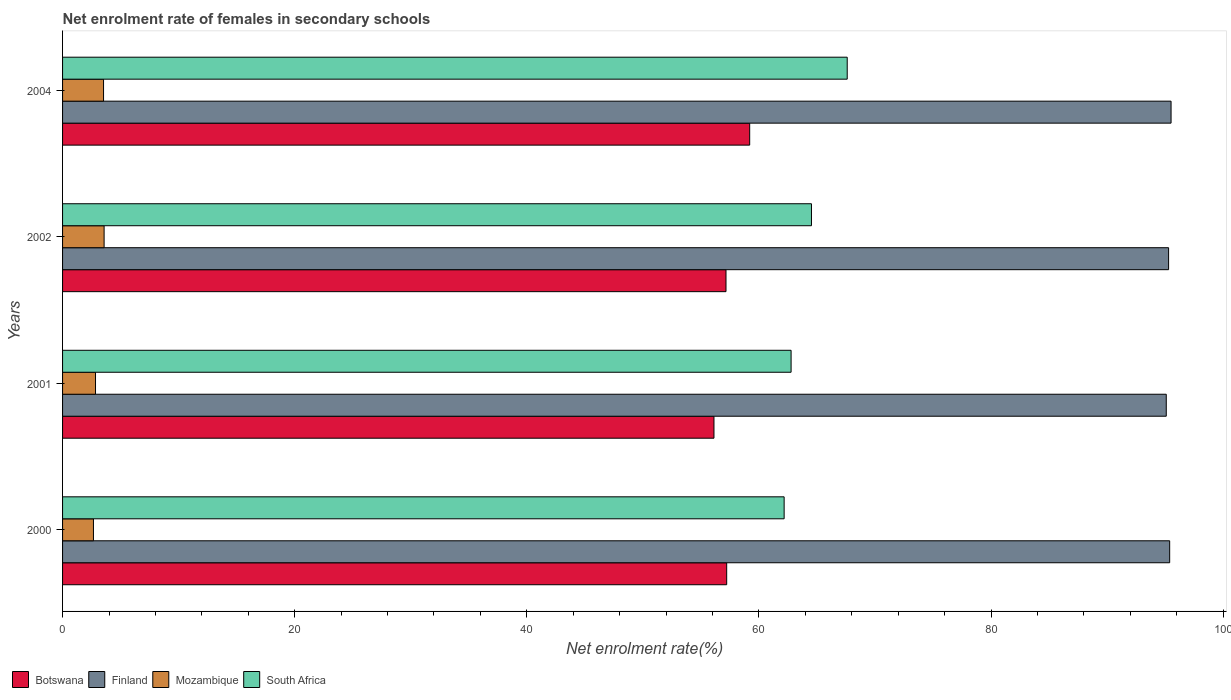How many different coloured bars are there?
Ensure brevity in your answer.  4. How many groups of bars are there?
Your answer should be compact. 4. How many bars are there on the 2nd tick from the top?
Your answer should be compact. 4. How many bars are there on the 2nd tick from the bottom?
Provide a succinct answer. 4. What is the label of the 2nd group of bars from the top?
Your answer should be compact. 2002. What is the net enrolment rate of females in secondary schools in Botswana in 2001?
Provide a succinct answer. 56.12. Across all years, what is the maximum net enrolment rate of females in secondary schools in Finland?
Offer a very short reply. 95.51. Across all years, what is the minimum net enrolment rate of females in secondary schools in South Africa?
Provide a succinct answer. 62.17. What is the total net enrolment rate of females in secondary schools in South Africa in the graph?
Offer a terse response. 257.07. What is the difference between the net enrolment rate of females in secondary schools in Botswana in 2000 and that in 2004?
Provide a succinct answer. -1.98. What is the difference between the net enrolment rate of females in secondary schools in Finland in 2004 and the net enrolment rate of females in secondary schools in South Africa in 2000?
Make the answer very short. 33.34. What is the average net enrolment rate of females in secondary schools in Finland per year?
Provide a short and direct response. 95.32. In the year 2002, what is the difference between the net enrolment rate of females in secondary schools in South Africa and net enrolment rate of females in secondary schools in Mozambique?
Offer a terse response. 60.94. What is the ratio of the net enrolment rate of females in secondary schools in Botswana in 2000 to that in 2002?
Provide a short and direct response. 1. Is the net enrolment rate of females in secondary schools in Botswana in 2000 less than that in 2001?
Offer a terse response. No. Is the difference between the net enrolment rate of females in secondary schools in South Africa in 2001 and 2002 greater than the difference between the net enrolment rate of females in secondary schools in Mozambique in 2001 and 2002?
Your answer should be compact. No. What is the difference between the highest and the second highest net enrolment rate of females in secondary schools in Mozambique?
Your response must be concise. 0.05. What is the difference between the highest and the lowest net enrolment rate of females in secondary schools in Mozambique?
Offer a terse response. 0.92. Is the sum of the net enrolment rate of females in secondary schools in Botswana in 2000 and 2004 greater than the maximum net enrolment rate of females in secondary schools in Mozambique across all years?
Make the answer very short. Yes. What does the 1st bar from the top in 2001 represents?
Provide a succinct answer. South Africa. What does the 4th bar from the bottom in 2000 represents?
Offer a very short reply. South Africa. Is it the case that in every year, the sum of the net enrolment rate of females in secondary schools in South Africa and net enrolment rate of females in secondary schools in Mozambique is greater than the net enrolment rate of females in secondary schools in Finland?
Provide a short and direct response. No. How many bars are there?
Provide a succinct answer. 16. How many years are there in the graph?
Your answer should be compact. 4. Does the graph contain grids?
Ensure brevity in your answer.  No. Where does the legend appear in the graph?
Offer a terse response. Bottom left. What is the title of the graph?
Give a very brief answer. Net enrolment rate of females in secondary schools. What is the label or title of the X-axis?
Provide a short and direct response. Net enrolment rate(%). What is the Net enrolment rate(%) in Botswana in 2000?
Offer a terse response. 57.22. What is the Net enrolment rate(%) in Finland in 2000?
Keep it short and to the point. 95.39. What is the Net enrolment rate(%) of Mozambique in 2000?
Make the answer very short. 2.66. What is the Net enrolment rate(%) of South Africa in 2000?
Keep it short and to the point. 62.17. What is the Net enrolment rate(%) of Botswana in 2001?
Make the answer very short. 56.12. What is the Net enrolment rate(%) of Finland in 2001?
Provide a short and direct response. 95.09. What is the Net enrolment rate(%) of Mozambique in 2001?
Offer a very short reply. 2.84. What is the Net enrolment rate(%) in South Africa in 2001?
Provide a succinct answer. 62.77. What is the Net enrolment rate(%) in Botswana in 2002?
Offer a terse response. 57.16. What is the Net enrolment rate(%) of Finland in 2002?
Provide a succinct answer. 95.29. What is the Net enrolment rate(%) of Mozambique in 2002?
Your answer should be very brief. 3.58. What is the Net enrolment rate(%) of South Africa in 2002?
Provide a short and direct response. 64.52. What is the Net enrolment rate(%) of Botswana in 2004?
Provide a succinct answer. 59.2. What is the Net enrolment rate(%) of Finland in 2004?
Make the answer very short. 95.51. What is the Net enrolment rate(%) in Mozambique in 2004?
Give a very brief answer. 3.53. What is the Net enrolment rate(%) of South Africa in 2004?
Your answer should be compact. 67.6. Across all years, what is the maximum Net enrolment rate(%) of Botswana?
Keep it short and to the point. 59.2. Across all years, what is the maximum Net enrolment rate(%) of Finland?
Your answer should be compact. 95.51. Across all years, what is the maximum Net enrolment rate(%) of Mozambique?
Make the answer very short. 3.58. Across all years, what is the maximum Net enrolment rate(%) in South Africa?
Offer a very short reply. 67.6. Across all years, what is the minimum Net enrolment rate(%) of Botswana?
Provide a short and direct response. 56.12. Across all years, what is the minimum Net enrolment rate(%) in Finland?
Your answer should be compact. 95.09. Across all years, what is the minimum Net enrolment rate(%) of Mozambique?
Your answer should be compact. 2.66. Across all years, what is the minimum Net enrolment rate(%) of South Africa?
Your answer should be compact. 62.17. What is the total Net enrolment rate(%) of Botswana in the graph?
Your answer should be very brief. 229.71. What is the total Net enrolment rate(%) in Finland in the graph?
Your response must be concise. 381.28. What is the total Net enrolment rate(%) of Mozambique in the graph?
Offer a terse response. 12.61. What is the total Net enrolment rate(%) of South Africa in the graph?
Give a very brief answer. 257.07. What is the difference between the Net enrolment rate(%) in Botswana in 2000 and that in 2001?
Your response must be concise. 1.1. What is the difference between the Net enrolment rate(%) of Finland in 2000 and that in 2001?
Your answer should be very brief. 0.29. What is the difference between the Net enrolment rate(%) in Mozambique in 2000 and that in 2001?
Your answer should be compact. -0.18. What is the difference between the Net enrolment rate(%) of South Africa in 2000 and that in 2001?
Offer a very short reply. -0.6. What is the difference between the Net enrolment rate(%) in Botswana in 2000 and that in 2002?
Ensure brevity in your answer.  0.06. What is the difference between the Net enrolment rate(%) in Finland in 2000 and that in 2002?
Provide a succinct answer. 0.09. What is the difference between the Net enrolment rate(%) of Mozambique in 2000 and that in 2002?
Your answer should be compact. -0.92. What is the difference between the Net enrolment rate(%) of South Africa in 2000 and that in 2002?
Your response must be concise. -2.36. What is the difference between the Net enrolment rate(%) of Botswana in 2000 and that in 2004?
Your answer should be very brief. -1.98. What is the difference between the Net enrolment rate(%) of Finland in 2000 and that in 2004?
Keep it short and to the point. -0.12. What is the difference between the Net enrolment rate(%) of Mozambique in 2000 and that in 2004?
Make the answer very short. -0.87. What is the difference between the Net enrolment rate(%) of South Africa in 2000 and that in 2004?
Offer a very short reply. -5.44. What is the difference between the Net enrolment rate(%) of Botswana in 2001 and that in 2002?
Offer a terse response. -1.04. What is the difference between the Net enrolment rate(%) of Finland in 2001 and that in 2002?
Your response must be concise. -0.2. What is the difference between the Net enrolment rate(%) in Mozambique in 2001 and that in 2002?
Offer a terse response. -0.74. What is the difference between the Net enrolment rate(%) of South Africa in 2001 and that in 2002?
Your answer should be very brief. -1.76. What is the difference between the Net enrolment rate(%) of Botswana in 2001 and that in 2004?
Make the answer very short. -3.08. What is the difference between the Net enrolment rate(%) in Finland in 2001 and that in 2004?
Your answer should be compact. -0.41. What is the difference between the Net enrolment rate(%) of Mozambique in 2001 and that in 2004?
Offer a terse response. -0.69. What is the difference between the Net enrolment rate(%) of South Africa in 2001 and that in 2004?
Your answer should be very brief. -4.84. What is the difference between the Net enrolment rate(%) in Botswana in 2002 and that in 2004?
Your answer should be very brief. -2.04. What is the difference between the Net enrolment rate(%) in Finland in 2002 and that in 2004?
Give a very brief answer. -0.21. What is the difference between the Net enrolment rate(%) in Mozambique in 2002 and that in 2004?
Provide a succinct answer. 0.05. What is the difference between the Net enrolment rate(%) of South Africa in 2002 and that in 2004?
Your answer should be compact. -3.08. What is the difference between the Net enrolment rate(%) in Botswana in 2000 and the Net enrolment rate(%) in Finland in 2001?
Make the answer very short. -37.87. What is the difference between the Net enrolment rate(%) in Botswana in 2000 and the Net enrolment rate(%) in Mozambique in 2001?
Make the answer very short. 54.38. What is the difference between the Net enrolment rate(%) in Botswana in 2000 and the Net enrolment rate(%) in South Africa in 2001?
Your answer should be very brief. -5.55. What is the difference between the Net enrolment rate(%) in Finland in 2000 and the Net enrolment rate(%) in Mozambique in 2001?
Your answer should be very brief. 92.55. What is the difference between the Net enrolment rate(%) of Finland in 2000 and the Net enrolment rate(%) of South Africa in 2001?
Offer a terse response. 32.62. What is the difference between the Net enrolment rate(%) in Mozambique in 2000 and the Net enrolment rate(%) in South Africa in 2001?
Your answer should be compact. -60.11. What is the difference between the Net enrolment rate(%) of Botswana in 2000 and the Net enrolment rate(%) of Finland in 2002?
Keep it short and to the point. -38.07. What is the difference between the Net enrolment rate(%) of Botswana in 2000 and the Net enrolment rate(%) of Mozambique in 2002?
Provide a succinct answer. 53.64. What is the difference between the Net enrolment rate(%) in Botswana in 2000 and the Net enrolment rate(%) in South Africa in 2002?
Give a very brief answer. -7.3. What is the difference between the Net enrolment rate(%) in Finland in 2000 and the Net enrolment rate(%) in Mozambique in 2002?
Give a very brief answer. 91.81. What is the difference between the Net enrolment rate(%) of Finland in 2000 and the Net enrolment rate(%) of South Africa in 2002?
Offer a terse response. 30.86. What is the difference between the Net enrolment rate(%) in Mozambique in 2000 and the Net enrolment rate(%) in South Africa in 2002?
Ensure brevity in your answer.  -61.86. What is the difference between the Net enrolment rate(%) of Botswana in 2000 and the Net enrolment rate(%) of Finland in 2004?
Your response must be concise. -38.29. What is the difference between the Net enrolment rate(%) in Botswana in 2000 and the Net enrolment rate(%) in Mozambique in 2004?
Ensure brevity in your answer.  53.69. What is the difference between the Net enrolment rate(%) of Botswana in 2000 and the Net enrolment rate(%) of South Africa in 2004?
Offer a very short reply. -10.38. What is the difference between the Net enrolment rate(%) in Finland in 2000 and the Net enrolment rate(%) in Mozambique in 2004?
Give a very brief answer. 91.86. What is the difference between the Net enrolment rate(%) of Finland in 2000 and the Net enrolment rate(%) of South Africa in 2004?
Your response must be concise. 27.78. What is the difference between the Net enrolment rate(%) in Mozambique in 2000 and the Net enrolment rate(%) in South Africa in 2004?
Your answer should be compact. -64.94. What is the difference between the Net enrolment rate(%) in Botswana in 2001 and the Net enrolment rate(%) in Finland in 2002?
Offer a very short reply. -39.17. What is the difference between the Net enrolment rate(%) in Botswana in 2001 and the Net enrolment rate(%) in Mozambique in 2002?
Your answer should be very brief. 52.54. What is the difference between the Net enrolment rate(%) in Botswana in 2001 and the Net enrolment rate(%) in South Africa in 2002?
Make the answer very short. -8.4. What is the difference between the Net enrolment rate(%) in Finland in 2001 and the Net enrolment rate(%) in Mozambique in 2002?
Give a very brief answer. 91.51. What is the difference between the Net enrolment rate(%) of Finland in 2001 and the Net enrolment rate(%) of South Africa in 2002?
Your response must be concise. 30.57. What is the difference between the Net enrolment rate(%) in Mozambique in 2001 and the Net enrolment rate(%) in South Africa in 2002?
Offer a very short reply. -61.68. What is the difference between the Net enrolment rate(%) of Botswana in 2001 and the Net enrolment rate(%) of Finland in 2004?
Your answer should be very brief. -39.38. What is the difference between the Net enrolment rate(%) of Botswana in 2001 and the Net enrolment rate(%) of Mozambique in 2004?
Offer a very short reply. 52.59. What is the difference between the Net enrolment rate(%) of Botswana in 2001 and the Net enrolment rate(%) of South Africa in 2004?
Provide a short and direct response. -11.48. What is the difference between the Net enrolment rate(%) of Finland in 2001 and the Net enrolment rate(%) of Mozambique in 2004?
Provide a succinct answer. 91.56. What is the difference between the Net enrolment rate(%) of Finland in 2001 and the Net enrolment rate(%) of South Africa in 2004?
Your response must be concise. 27.49. What is the difference between the Net enrolment rate(%) of Mozambique in 2001 and the Net enrolment rate(%) of South Africa in 2004?
Make the answer very short. -64.76. What is the difference between the Net enrolment rate(%) of Botswana in 2002 and the Net enrolment rate(%) of Finland in 2004?
Give a very brief answer. -38.35. What is the difference between the Net enrolment rate(%) in Botswana in 2002 and the Net enrolment rate(%) in Mozambique in 2004?
Your answer should be compact. 53.63. What is the difference between the Net enrolment rate(%) in Botswana in 2002 and the Net enrolment rate(%) in South Africa in 2004?
Your answer should be very brief. -10.44. What is the difference between the Net enrolment rate(%) in Finland in 2002 and the Net enrolment rate(%) in Mozambique in 2004?
Offer a terse response. 91.76. What is the difference between the Net enrolment rate(%) of Finland in 2002 and the Net enrolment rate(%) of South Africa in 2004?
Your answer should be compact. 27.69. What is the difference between the Net enrolment rate(%) in Mozambique in 2002 and the Net enrolment rate(%) in South Africa in 2004?
Your answer should be very brief. -64.02. What is the average Net enrolment rate(%) in Botswana per year?
Offer a very short reply. 57.43. What is the average Net enrolment rate(%) in Finland per year?
Your answer should be very brief. 95.32. What is the average Net enrolment rate(%) of Mozambique per year?
Offer a very short reply. 3.15. What is the average Net enrolment rate(%) in South Africa per year?
Offer a very short reply. 64.27. In the year 2000, what is the difference between the Net enrolment rate(%) of Botswana and Net enrolment rate(%) of Finland?
Your answer should be compact. -38.17. In the year 2000, what is the difference between the Net enrolment rate(%) in Botswana and Net enrolment rate(%) in Mozambique?
Offer a very short reply. 54.56. In the year 2000, what is the difference between the Net enrolment rate(%) in Botswana and Net enrolment rate(%) in South Africa?
Provide a succinct answer. -4.95. In the year 2000, what is the difference between the Net enrolment rate(%) of Finland and Net enrolment rate(%) of Mozambique?
Your response must be concise. 92.72. In the year 2000, what is the difference between the Net enrolment rate(%) in Finland and Net enrolment rate(%) in South Africa?
Your answer should be very brief. 33.22. In the year 2000, what is the difference between the Net enrolment rate(%) of Mozambique and Net enrolment rate(%) of South Africa?
Your answer should be very brief. -59.51. In the year 2001, what is the difference between the Net enrolment rate(%) of Botswana and Net enrolment rate(%) of Finland?
Make the answer very short. -38.97. In the year 2001, what is the difference between the Net enrolment rate(%) of Botswana and Net enrolment rate(%) of Mozambique?
Give a very brief answer. 53.28. In the year 2001, what is the difference between the Net enrolment rate(%) of Botswana and Net enrolment rate(%) of South Africa?
Provide a short and direct response. -6.64. In the year 2001, what is the difference between the Net enrolment rate(%) of Finland and Net enrolment rate(%) of Mozambique?
Offer a terse response. 92.25. In the year 2001, what is the difference between the Net enrolment rate(%) in Finland and Net enrolment rate(%) in South Africa?
Offer a very short reply. 32.32. In the year 2001, what is the difference between the Net enrolment rate(%) in Mozambique and Net enrolment rate(%) in South Africa?
Ensure brevity in your answer.  -59.93. In the year 2002, what is the difference between the Net enrolment rate(%) in Botswana and Net enrolment rate(%) in Finland?
Your answer should be compact. -38.13. In the year 2002, what is the difference between the Net enrolment rate(%) of Botswana and Net enrolment rate(%) of Mozambique?
Your answer should be compact. 53.58. In the year 2002, what is the difference between the Net enrolment rate(%) of Botswana and Net enrolment rate(%) of South Africa?
Offer a very short reply. -7.36. In the year 2002, what is the difference between the Net enrolment rate(%) in Finland and Net enrolment rate(%) in Mozambique?
Your response must be concise. 91.71. In the year 2002, what is the difference between the Net enrolment rate(%) of Finland and Net enrolment rate(%) of South Africa?
Your response must be concise. 30.77. In the year 2002, what is the difference between the Net enrolment rate(%) in Mozambique and Net enrolment rate(%) in South Africa?
Provide a succinct answer. -60.94. In the year 2004, what is the difference between the Net enrolment rate(%) of Botswana and Net enrolment rate(%) of Finland?
Keep it short and to the point. -36.31. In the year 2004, what is the difference between the Net enrolment rate(%) in Botswana and Net enrolment rate(%) in Mozambique?
Ensure brevity in your answer.  55.67. In the year 2004, what is the difference between the Net enrolment rate(%) of Botswana and Net enrolment rate(%) of South Africa?
Make the answer very short. -8.4. In the year 2004, what is the difference between the Net enrolment rate(%) in Finland and Net enrolment rate(%) in Mozambique?
Your answer should be compact. 91.98. In the year 2004, what is the difference between the Net enrolment rate(%) in Finland and Net enrolment rate(%) in South Africa?
Your answer should be compact. 27.9. In the year 2004, what is the difference between the Net enrolment rate(%) in Mozambique and Net enrolment rate(%) in South Africa?
Offer a very short reply. -64.07. What is the ratio of the Net enrolment rate(%) in Botswana in 2000 to that in 2001?
Keep it short and to the point. 1.02. What is the ratio of the Net enrolment rate(%) of Finland in 2000 to that in 2001?
Keep it short and to the point. 1. What is the ratio of the Net enrolment rate(%) of Mozambique in 2000 to that in 2001?
Keep it short and to the point. 0.94. What is the ratio of the Net enrolment rate(%) in Finland in 2000 to that in 2002?
Your answer should be very brief. 1. What is the ratio of the Net enrolment rate(%) in Mozambique in 2000 to that in 2002?
Your answer should be compact. 0.74. What is the ratio of the Net enrolment rate(%) of South Africa in 2000 to that in 2002?
Your answer should be compact. 0.96. What is the ratio of the Net enrolment rate(%) of Botswana in 2000 to that in 2004?
Your answer should be very brief. 0.97. What is the ratio of the Net enrolment rate(%) of Finland in 2000 to that in 2004?
Make the answer very short. 1. What is the ratio of the Net enrolment rate(%) of Mozambique in 2000 to that in 2004?
Ensure brevity in your answer.  0.75. What is the ratio of the Net enrolment rate(%) in South Africa in 2000 to that in 2004?
Ensure brevity in your answer.  0.92. What is the ratio of the Net enrolment rate(%) of Botswana in 2001 to that in 2002?
Provide a succinct answer. 0.98. What is the ratio of the Net enrolment rate(%) in Finland in 2001 to that in 2002?
Ensure brevity in your answer.  1. What is the ratio of the Net enrolment rate(%) in Mozambique in 2001 to that in 2002?
Provide a succinct answer. 0.79. What is the ratio of the Net enrolment rate(%) in South Africa in 2001 to that in 2002?
Offer a terse response. 0.97. What is the ratio of the Net enrolment rate(%) of Botswana in 2001 to that in 2004?
Give a very brief answer. 0.95. What is the ratio of the Net enrolment rate(%) of Finland in 2001 to that in 2004?
Offer a terse response. 1. What is the ratio of the Net enrolment rate(%) in Mozambique in 2001 to that in 2004?
Keep it short and to the point. 0.8. What is the ratio of the Net enrolment rate(%) in South Africa in 2001 to that in 2004?
Ensure brevity in your answer.  0.93. What is the ratio of the Net enrolment rate(%) of Botswana in 2002 to that in 2004?
Keep it short and to the point. 0.97. What is the ratio of the Net enrolment rate(%) in Mozambique in 2002 to that in 2004?
Offer a terse response. 1.01. What is the ratio of the Net enrolment rate(%) in South Africa in 2002 to that in 2004?
Your answer should be compact. 0.95. What is the difference between the highest and the second highest Net enrolment rate(%) of Botswana?
Your response must be concise. 1.98. What is the difference between the highest and the second highest Net enrolment rate(%) of Finland?
Your response must be concise. 0.12. What is the difference between the highest and the second highest Net enrolment rate(%) of Mozambique?
Provide a short and direct response. 0.05. What is the difference between the highest and the second highest Net enrolment rate(%) in South Africa?
Keep it short and to the point. 3.08. What is the difference between the highest and the lowest Net enrolment rate(%) of Botswana?
Keep it short and to the point. 3.08. What is the difference between the highest and the lowest Net enrolment rate(%) of Finland?
Make the answer very short. 0.41. What is the difference between the highest and the lowest Net enrolment rate(%) of Mozambique?
Keep it short and to the point. 0.92. What is the difference between the highest and the lowest Net enrolment rate(%) in South Africa?
Your answer should be compact. 5.44. 